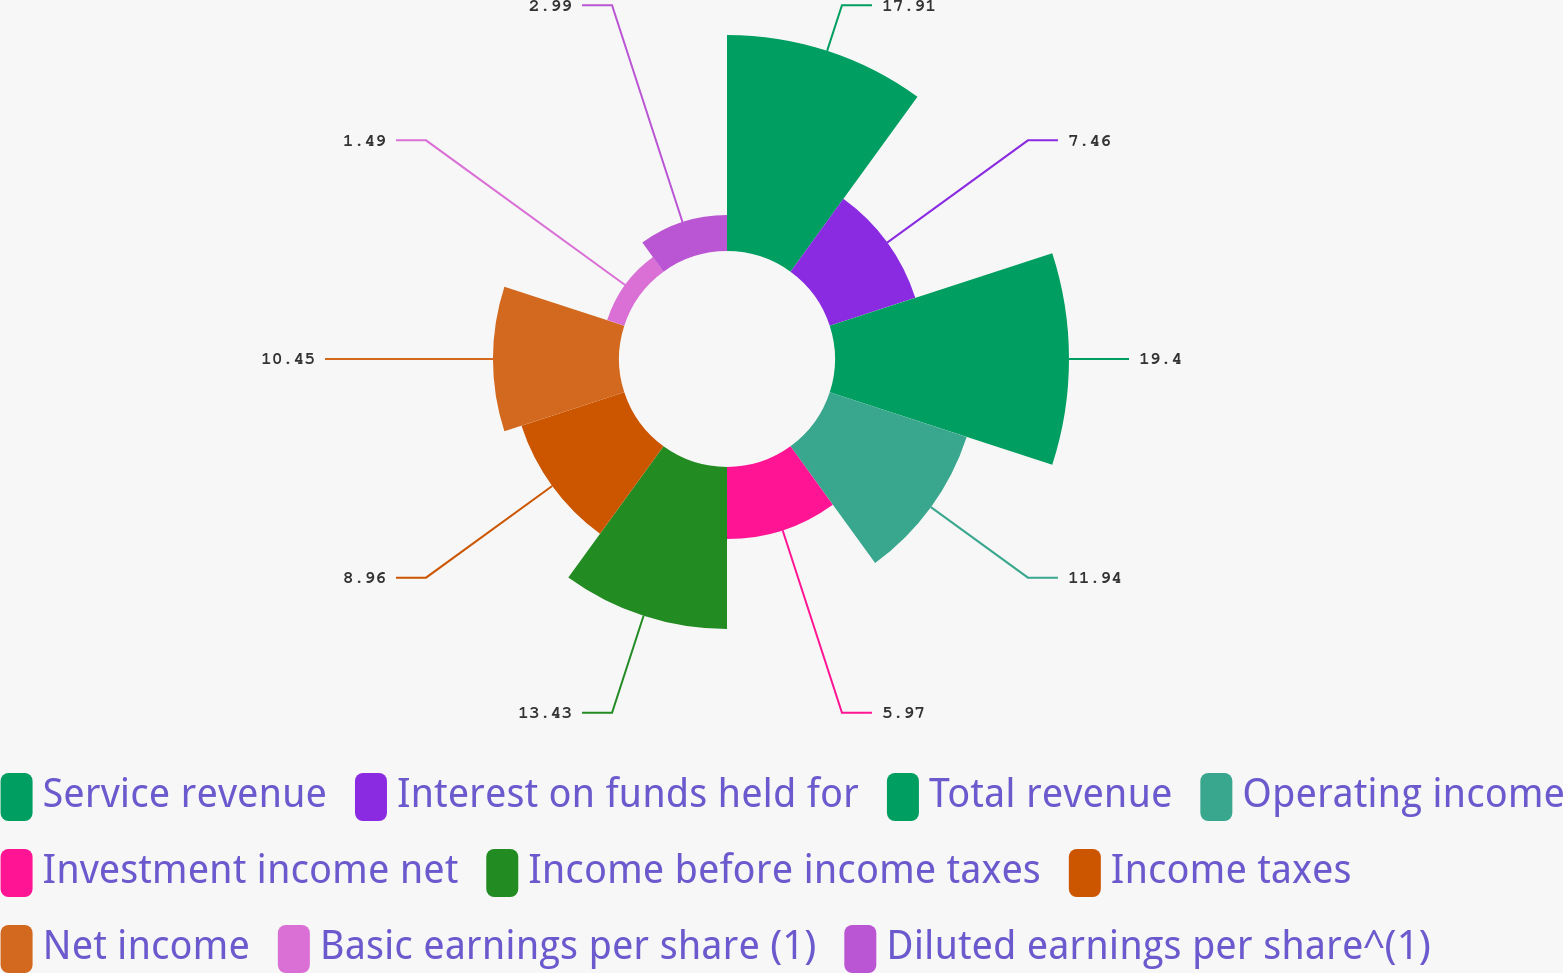Convert chart. <chart><loc_0><loc_0><loc_500><loc_500><pie_chart><fcel>Service revenue<fcel>Interest on funds held for<fcel>Total revenue<fcel>Operating income<fcel>Investment income net<fcel>Income before income taxes<fcel>Income taxes<fcel>Net income<fcel>Basic earnings per share (1)<fcel>Diluted earnings per share^(1)<nl><fcel>17.91%<fcel>7.46%<fcel>19.4%<fcel>11.94%<fcel>5.97%<fcel>13.43%<fcel>8.96%<fcel>10.45%<fcel>1.49%<fcel>2.99%<nl></chart> 